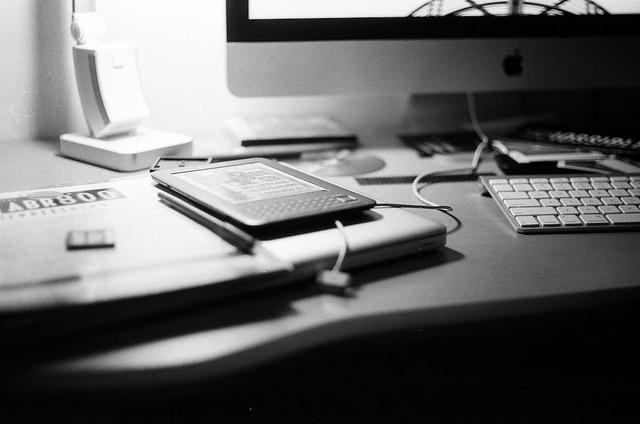Is the white cord from the computer connected to anything?
Concise answer only. No. How has technology altered human interactions?
Be succinct. Makes things easier. What electronic is pictured here?
Be succinct. Kindle. 